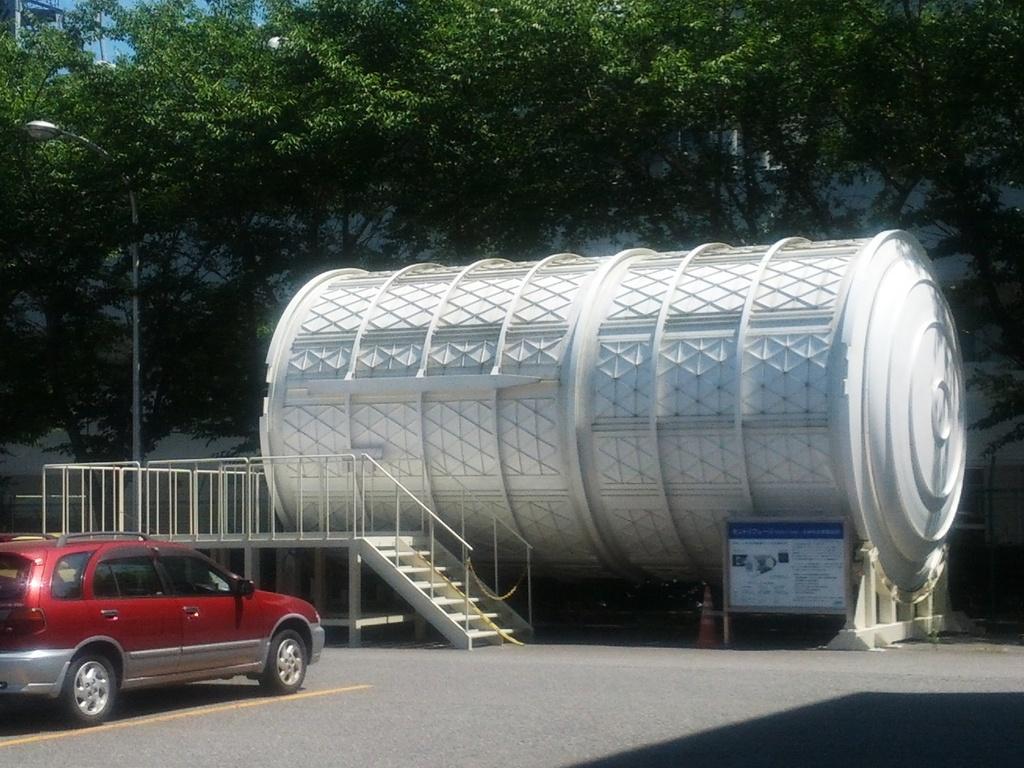How would you summarize this image in a sentence or two? In this image I can see a vehicle in red color, background I can see a tank in white color, I can also see few stairs, a light pole, trees in green color and the sky is in blue color. 